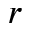Convert formula to latex. <formula><loc_0><loc_0><loc_500><loc_500>r</formula> 